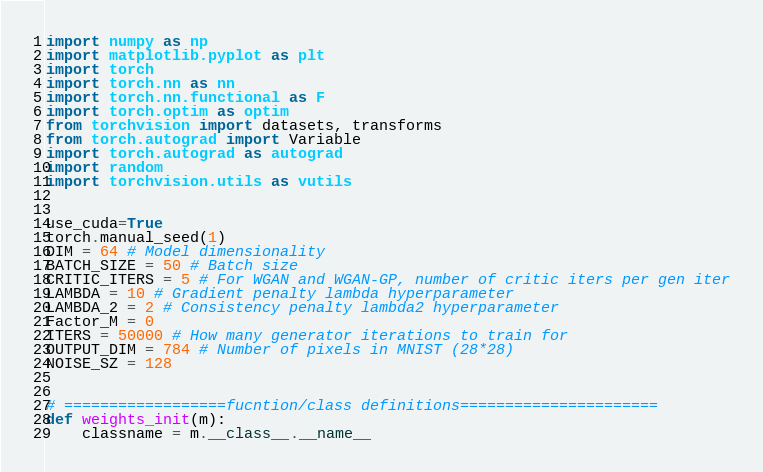Convert code to text. <code><loc_0><loc_0><loc_500><loc_500><_Python_>import numpy as np
import matplotlib.pyplot as plt
import torch
import torch.nn as nn
import torch.nn.functional as F
import torch.optim as optim
from torchvision import datasets, transforms
from torch.autograd import Variable
import torch.autograd as autograd
import random
import torchvision.utils as vutils


use_cuda=True
torch.manual_seed(1)
DIM = 64 # Model dimensionality
BATCH_SIZE = 50 # Batch size
CRITIC_ITERS = 5 # For WGAN and WGAN-GP, number of critic iters per gen iter
LAMBDA = 10 # Gradient penalty lambda hyperparameter
LAMBDA_2 = 2 # Consistency penalty lambda2 hyperparameter
Factor_M = 0
ITERS = 50000 # How many generator iterations to train for
OUTPUT_DIM = 784 # Number of pixels in MNIST (28*28)
NOISE_SZ = 128


# ==================fucntion/class definitions======================
def weights_init(m):
    classname = m.__class__.__name__</code> 